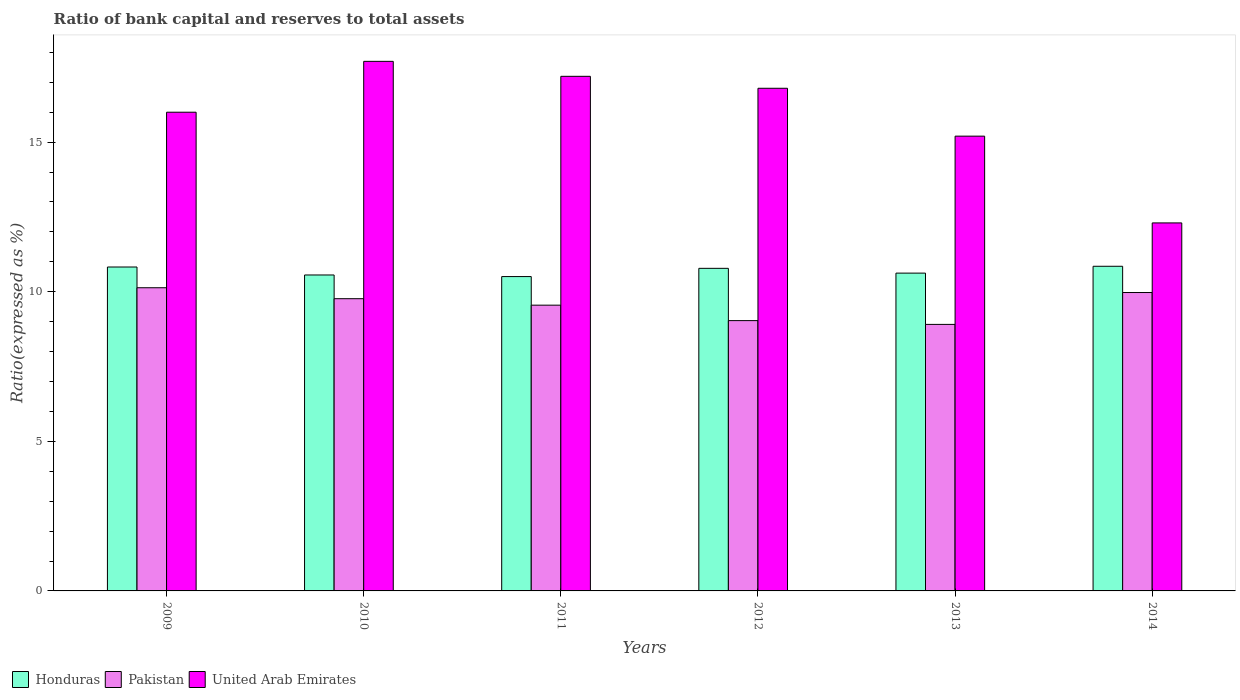How many different coloured bars are there?
Your response must be concise. 3. Are the number of bars per tick equal to the number of legend labels?
Ensure brevity in your answer.  Yes. Are the number of bars on each tick of the X-axis equal?
Ensure brevity in your answer.  Yes. How many bars are there on the 2nd tick from the left?
Make the answer very short. 3. In how many cases, is the number of bars for a given year not equal to the number of legend labels?
Your answer should be compact. 0. What is the ratio of bank capital and reserves to total assets in United Arab Emirates in 2010?
Provide a short and direct response. 17.7. Across all years, what is the maximum ratio of bank capital and reserves to total assets in Pakistan?
Your answer should be very brief. 10.13. Across all years, what is the minimum ratio of bank capital and reserves to total assets in United Arab Emirates?
Your answer should be very brief. 12.3. In which year was the ratio of bank capital and reserves to total assets in Honduras minimum?
Provide a short and direct response. 2011. What is the total ratio of bank capital and reserves to total assets in Pakistan in the graph?
Offer a terse response. 57.37. What is the difference between the ratio of bank capital and reserves to total assets in United Arab Emirates in 2010 and the ratio of bank capital and reserves to total assets in Pakistan in 2014?
Give a very brief answer. 7.73. What is the average ratio of bank capital and reserves to total assets in Pakistan per year?
Provide a succinct answer. 9.56. In the year 2013, what is the difference between the ratio of bank capital and reserves to total assets in Honduras and ratio of bank capital and reserves to total assets in Pakistan?
Your answer should be compact. 1.71. What is the ratio of the ratio of bank capital and reserves to total assets in Pakistan in 2010 to that in 2014?
Provide a succinct answer. 0.98. Is the ratio of bank capital and reserves to total assets in Honduras in 2013 less than that in 2014?
Offer a very short reply. Yes. What is the difference between the highest and the lowest ratio of bank capital and reserves to total assets in United Arab Emirates?
Make the answer very short. 5.4. Is the sum of the ratio of bank capital and reserves to total assets in Pakistan in 2009 and 2013 greater than the maximum ratio of bank capital and reserves to total assets in United Arab Emirates across all years?
Ensure brevity in your answer.  Yes. What does the 1st bar from the left in 2012 represents?
Provide a succinct answer. Honduras. What does the 2nd bar from the right in 2009 represents?
Offer a terse response. Pakistan. Is it the case that in every year, the sum of the ratio of bank capital and reserves to total assets in Honduras and ratio of bank capital and reserves to total assets in Pakistan is greater than the ratio of bank capital and reserves to total assets in United Arab Emirates?
Provide a succinct answer. Yes. How many bars are there?
Give a very brief answer. 18. What is the difference between two consecutive major ticks on the Y-axis?
Your answer should be compact. 5. Are the values on the major ticks of Y-axis written in scientific E-notation?
Your answer should be compact. No. How are the legend labels stacked?
Make the answer very short. Horizontal. What is the title of the graph?
Give a very brief answer. Ratio of bank capital and reserves to total assets. Does "Chile" appear as one of the legend labels in the graph?
Ensure brevity in your answer.  No. What is the label or title of the X-axis?
Make the answer very short. Years. What is the label or title of the Y-axis?
Ensure brevity in your answer.  Ratio(expressed as %). What is the Ratio(expressed as %) of Honduras in 2009?
Your response must be concise. 10.83. What is the Ratio(expressed as %) of Pakistan in 2009?
Offer a terse response. 10.13. What is the Ratio(expressed as %) in Honduras in 2010?
Offer a terse response. 10.56. What is the Ratio(expressed as %) in Pakistan in 2010?
Ensure brevity in your answer.  9.77. What is the Ratio(expressed as %) of United Arab Emirates in 2010?
Give a very brief answer. 17.7. What is the Ratio(expressed as %) of Honduras in 2011?
Ensure brevity in your answer.  10.51. What is the Ratio(expressed as %) of Pakistan in 2011?
Provide a succinct answer. 9.55. What is the Ratio(expressed as %) in United Arab Emirates in 2011?
Offer a very short reply. 17.2. What is the Ratio(expressed as %) of Honduras in 2012?
Provide a short and direct response. 10.78. What is the Ratio(expressed as %) in Pakistan in 2012?
Your answer should be very brief. 9.03. What is the Ratio(expressed as %) of United Arab Emirates in 2012?
Ensure brevity in your answer.  16.8. What is the Ratio(expressed as %) of Honduras in 2013?
Your answer should be very brief. 10.62. What is the Ratio(expressed as %) in Pakistan in 2013?
Your response must be concise. 8.91. What is the Ratio(expressed as %) of United Arab Emirates in 2013?
Offer a very short reply. 15.2. What is the Ratio(expressed as %) of Honduras in 2014?
Give a very brief answer. 10.85. What is the Ratio(expressed as %) in Pakistan in 2014?
Your response must be concise. 9.97. Across all years, what is the maximum Ratio(expressed as %) in Honduras?
Give a very brief answer. 10.85. Across all years, what is the maximum Ratio(expressed as %) of Pakistan?
Your answer should be compact. 10.13. Across all years, what is the maximum Ratio(expressed as %) in United Arab Emirates?
Provide a short and direct response. 17.7. Across all years, what is the minimum Ratio(expressed as %) of Honduras?
Your response must be concise. 10.51. Across all years, what is the minimum Ratio(expressed as %) in Pakistan?
Your response must be concise. 8.91. What is the total Ratio(expressed as %) of Honduras in the graph?
Make the answer very short. 64.15. What is the total Ratio(expressed as %) in Pakistan in the graph?
Provide a succinct answer. 57.37. What is the total Ratio(expressed as %) in United Arab Emirates in the graph?
Your response must be concise. 95.2. What is the difference between the Ratio(expressed as %) of Honduras in 2009 and that in 2010?
Provide a short and direct response. 0.27. What is the difference between the Ratio(expressed as %) of Pakistan in 2009 and that in 2010?
Your answer should be compact. 0.37. What is the difference between the Ratio(expressed as %) of United Arab Emirates in 2009 and that in 2010?
Keep it short and to the point. -1.7. What is the difference between the Ratio(expressed as %) of Honduras in 2009 and that in 2011?
Give a very brief answer. 0.32. What is the difference between the Ratio(expressed as %) of Pakistan in 2009 and that in 2011?
Keep it short and to the point. 0.58. What is the difference between the Ratio(expressed as %) in Honduras in 2009 and that in 2012?
Make the answer very short. 0.04. What is the difference between the Ratio(expressed as %) in Pakistan in 2009 and that in 2012?
Keep it short and to the point. 1.1. What is the difference between the Ratio(expressed as %) in United Arab Emirates in 2009 and that in 2012?
Ensure brevity in your answer.  -0.8. What is the difference between the Ratio(expressed as %) of Honduras in 2009 and that in 2013?
Your answer should be compact. 0.2. What is the difference between the Ratio(expressed as %) in Pakistan in 2009 and that in 2013?
Provide a succinct answer. 1.23. What is the difference between the Ratio(expressed as %) of United Arab Emirates in 2009 and that in 2013?
Your response must be concise. 0.8. What is the difference between the Ratio(expressed as %) in Honduras in 2009 and that in 2014?
Provide a short and direct response. -0.02. What is the difference between the Ratio(expressed as %) in Pakistan in 2009 and that in 2014?
Make the answer very short. 0.16. What is the difference between the Ratio(expressed as %) in Honduras in 2010 and that in 2011?
Offer a terse response. 0.05. What is the difference between the Ratio(expressed as %) in Pakistan in 2010 and that in 2011?
Offer a terse response. 0.22. What is the difference between the Ratio(expressed as %) of Honduras in 2010 and that in 2012?
Your response must be concise. -0.22. What is the difference between the Ratio(expressed as %) in Pakistan in 2010 and that in 2012?
Give a very brief answer. 0.73. What is the difference between the Ratio(expressed as %) in United Arab Emirates in 2010 and that in 2012?
Keep it short and to the point. 0.9. What is the difference between the Ratio(expressed as %) in Honduras in 2010 and that in 2013?
Your response must be concise. -0.06. What is the difference between the Ratio(expressed as %) of Pakistan in 2010 and that in 2013?
Offer a terse response. 0.86. What is the difference between the Ratio(expressed as %) of United Arab Emirates in 2010 and that in 2013?
Offer a very short reply. 2.5. What is the difference between the Ratio(expressed as %) of Honduras in 2010 and that in 2014?
Make the answer very short. -0.29. What is the difference between the Ratio(expressed as %) in Pakistan in 2010 and that in 2014?
Offer a very short reply. -0.21. What is the difference between the Ratio(expressed as %) of Honduras in 2011 and that in 2012?
Your answer should be compact. -0.28. What is the difference between the Ratio(expressed as %) in Pakistan in 2011 and that in 2012?
Make the answer very short. 0.52. What is the difference between the Ratio(expressed as %) in Honduras in 2011 and that in 2013?
Offer a terse response. -0.12. What is the difference between the Ratio(expressed as %) in Pakistan in 2011 and that in 2013?
Make the answer very short. 0.64. What is the difference between the Ratio(expressed as %) in United Arab Emirates in 2011 and that in 2013?
Ensure brevity in your answer.  2. What is the difference between the Ratio(expressed as %) in Honduras in 2011 and that in 2014?
Your response must be concise. -0.34. What is the difference between the Ratio(expressed as %) of Pakistan in 2011 and that in 2014?
Give a very brief answer. -0.42. What is the difference between the Ratio(expressed as %) of United Arab Emirates in 2011 and that in 2014?
Ensure brevity in your answer.  4.9. What is the difference between the Ratio(expressed as %) of Honduras in 2012 and that in 2013?
Offer a terse response. 0.16. What is the difference between the Ratio(expressed as %) in Pakistan in 2012 and that in 2013?
Your answer should be very brief. 0.13. What is the difference between the Ratio(expressed as %) of United Arab Emirates in 2012 and that in 2013?
Provide a succinct answer. 1.6. What is the difference between the Ratio(expressed as %) in Honduras in 2012 and that in 2014?
Your answer should be very brief. -0.07. What is the difference between the Ratio(expressed as %) in Pakistan in 2012 and that in 2014?
Your answer should be very brief. -0.94. What is the difference between the Ratio(expressed as %) of Honduras in 2013 and that in 2014?
Keep it short and to the point. -0.23. What is the difference between the Ratio(expressed as %) of Pakistan in 2013 and that in 2014?
Keep it short and to the point. -1.07. What is the difference between the Ratio(expressed as %) of Honduras in 2009 and the Ratio(expressed as %) of Pakistan in 2010?
Your response must be concise. 1.06. What is the difference between the Ratio(expressed as %) in Honduras in 2009 and the Ratio(expressed as %) in United Arab Emirates in 2010?
Your response must be concise. -6.87. What is the difference between the Ratio(expressed as %) of Pakistan in 2009 and the Ratio(expressed as %) of United Arab Emirates in 2010?
Give a very brief answer. -7.57. What is the difference between the Ratio(expressed as %) of Honduras in 2009 and the Ratio(expressed as %) of Pakistan in 2011?
Ensure brevity in your answer.  1.27. What is the difference between the Ratio(expressed as %) in Honduras in 2009 and the Ratio(expressed as %) in United Arab Emirates in 2011?
Offer a terse response. -6.37. What is the difference between the Ratio(expressed as %) in Pakistan in 2009 and the Ratio(expressed as %) in United Arab Emirates in 2011?
Offer a terse response. -7.07. What is the difference between the Ratio(expressed as %) in Honduras in 2009 and the Ratio(expressed as %) in Pakistan in 2012?
Keep it short and to the point. 1.79. What is the difference between the Ratio(expressed as %) of Honduras in 2009 and the Ratio(expressed as %) of United Arab Emirates in 2012?
Offer a very short reply. -5.97. What is the difference between the Ratio(expressed as %) of Pakistan in 2009 and the Ratio(expressed as %) of United Arab Emirates in 2012?
Provide a short and direct response. -6.67. What is the difference between the Ratio(expressed as %) in Honduras in 2009 and the Ratio(expressed as %) in Pakistan in 2013?
Make the answer very short. 1.92. What is the difference between the Ratio(expressed as %) of Honduras in 2009 and the Ratio(expressed as %) of United Arab Emirates in 2013?
Your response must be concise. -4.37. What is the difference between the Ratio(expressed as %) in Pakistan in 2009 and the Ratio(expressed as %) in United Arab Emirates in 2013?
Offer a very short reply. -5.07. What is the difference between the Ratio(expressed as %) of Honduras in 2009 and the Ratio(expressed as %) of Pakistan in 2014?
Make the answer very short. 0.85. What is the difference between the Ratio(expressed as %) in Honduras in 2009 and the Ratio(expressed as %) in United Arab Emirates in 2014?
Keep it short and to the point. -1.47. What is the difference between the Ratio(expressed as %) in Pakistan in 2009 and the Ratio(expressed as %) in United Arab Emirates in 2014?
Make the answer very short. -2.17. What is the difference between the Ratio(expressed as %) in Honduras in 2010 and the Ratio(expressed as %) in Pakistan in 2011?
Offer a very short reply. 1.01. What is the difference between the Ratio(expressed as %) of Honduras in 2010 and the Ratio(expressed as %) of United Arab Emirates in 2011?
Make the answer very short. -6.64. What is the difference between the Ratio(expressed as %) of Pakistan in 2010 and the Ratio(expressed as %) of United Arab Emirates in 2011?
Ensure brevity in your answer.  -7.43. What is the difference between the Ratio(expressed as %) of Honduras in 2010 and the Ratio(expressed as %) of Pakistan in 2012?
Give a very brief answer. 1.53. What is the difference between the Ratio(expressed as %) in Honduras in 2010 and the Ratio(expressed as %) in United Arab Emirates in 2012?
Your answer should be very brief. -6.24. What is the difference between the Ratio(expressed as %) of Pakistan in 2010 and the Ratio(expressed as %) of United Arab Emirates in 2012?
Ensure brevity in your answer.  -7.03. What is the difference between the Ratio(expressed as %) of Honduras in 2010 and the Ratio(expressed as %) of Pakistan in 2013?
Your response must be concise. 1.65. What is the difference between the Ratio(expressed as %) of Honduras in 2010 and the Ratio(expressed as %) of United Arab Emirates in 2013?
Your answer should be very brief. -4.64. What is the difference between the Ratio(expressed as %) of Pakistan in 2010 and the Ratio(expressed as %) of United Arab Emirates in 2013?
Provide a succinct answer. -5.43. What is the difference between the Ratio(expressed as %) in Honduras in 2010 and the Ratio(expressed as %) in Pakistan in 2014?
Offer a terse response. 0.59. What is the difference between the Ratio(expressed as %) in Honduras in 2010 and the Ratio(expressed as %) in United Arab Emirates in 2014?
Your response must be concise. -1.74. What is the difference between the Ratio(expressed as %) of Pakistan in 2010 and the Ratio(expressed as %) of United Arab Emirates in 2014?
Offer a terse response. -2.53. What is the difference between the Ratio(expressed as %) in Honduras in 2011 and the Ratio(expressed as %) in Pakistan in 2012?
Provide a short and direct response. 1.47. What is the difference between the Ratio(expressed as %) of Honduras in 2011 and the Ratio(expressed as %) of United Arab Emirates in 2012?
Ensure brevity in your answer.  -6.29. What is the difference between the Ratio(expressed as %) of Pakistan in 2011 and the Ratio(expressed as %) of United Arab Emirates in 2012?
Your answer should be compact. -7.25. What is the difference between the Ratio(expressed as %) in Honduras in 2011 and the Ratio(expressed as %) in Pakistan in 2013?
Keep it short and to the point. 1.6. What is the difference between the Ratio(expressed as %) of Honduras in 2011 and the Ratio(expressed as %) of United Arab Emirates in 2013?
Offer a very short reply. -4.69. What is the difference between the Ratio(expressed as %) in Pakistan in 2011 and the Ratio(expressed as %) in United Arab Emirates in 2013?
Provide a succinct answer. -5.65. What is the difference between the Ratio(expressed as %) of Honduras in 2011 and the Ratio(expressed as %) of Pakistan in 2014?
Your answer should be very brief. 0.53. What is the difference between the Ratio(expressed as %) of Honduras in 2011 and the Ratio(expressed as %) of United Arab Emirates in 2014?
Provide a short and direct response. -1.79. What is the difference between the Ratio(expressed as %) of Pakistan in 2011 and the Ratio(expressed as %) of United Arab Emirates in 2014?
Your response must be concise. -2.75. What is the difference between the Ratio(expressed as %) of Honduras in 2012 and the Ratio(expressed as %) of Pakistan in 2013?
Give a very brief answer. 1.87. What is the difference between the Ratio(expressed as %) of Honduras in 2012 and the Ratio(expressed as %) of United Arab Emirates in 2013?
Your answer should be compact. -4.42. What is the difference between the Ratio(expressed as %) of Pakistan in 2012 and the Ratio(expressed as %) of United Arab Emirates in 2013?
Provide a short and direct response. -6.17. What is the difference between the Ratio(expressed as %) of Honduras in 2012 and the Ratio(expressed as %) of Pakistan in 2014?
Ensure brevity in your answer.  0.81. What is the difference between the Ratio(expressed as %) of Honduras in 2012 and the Ratio(expressed as %) of United Arab Emirates in 2014?
Provide a short and direct response. -1.52. What is the difference between the Ratio(expressed as %) in Pakistan in 2012 and the Ratio(expressed as %) in United Arab Emirates in 2014?
Offer a terse response. -3.27. What is the difference between the Ratio(expressed as %) in Honduras in 2013 and the Ratio(expressed as %) in Pakistan in 2014?
Your answer should be very brief. 0.65. What is the difference between the Ratio(expressed as %) of Honduras in 2013 and the Ratio(expressed as %) of United Arab Emirates in 2014?
Your answer should be compact. -1.68. What is the difference between the Ratio(expressed as %) of Pakistan in 2013 and the Ratio(expressed as %) of United Arab Emirates in 2014?
Your response must be concise. -3.39. What is the average Ratio(expressed as %) of Honduras per year?
Your answer should be compact. 10.69. What is the average Ratio(expressed as %) in Pakistan per year?
Provide a succinct answer. 9.56. What is the average Ratio(expressed as %) of United Arab Emirates per year?
Provide a succinct answer. 15.87. In the year 2009, what is the difference between the Ratio(expressed as %) in Honduras and Ratio(expressed as %) in Pakistan?
Give a very brief answer. 0.69. In the year 2009, what is the difference between the Ratio(expressed as %) in Honduras and Ratio(expressed as %) in United Arab Emirates?
Your response must be concise. -5.17. In the year 2009, what is the difference between the Ratio(expressed as %) in Pakistan and Ratio(expressed as %) in United Arab Emirates?
Offer a very short reply. -5.87. In the year 2010, what is the difference between the Ratio(expressed as %) of Honduras and Ratio(expressed as %) of Pakistan?
Provide a succinct answer. 0.79. In the year 2010, what is the difference between the Ratio(expressed as %) in Honduras and Ratio(expressed as %) in United Arab Emirates?
Your answer should be very brief. -7.14. In the year 2010, what is the difference between the Ratio(expressed as %) in Pakistan and Ratio(expressed as %) in United Arab Emirates?
Make the answer very short. -7.93. In the year 2011, what is the difference between the Ratio(expressed as %) of Honduras and Ratio(expressed as %) of Pakistan?
Give a very brief answer. 0.96. In the year 2011, what is the difference between the Ratio(expressed as %) in Honduras and Ratio(expressed as %) in United Arab Emirates?
Your response must be concise. -6.69. In the year 2011, what is the difference between the Ratio(expressed as %) in Pakistan and Ratio(expressed as %) in United Arab Emirates?
Make the answer very short. -7.65. In the year 2012, what is the difference between the Ratio(expressed as %) of Honduras and Ratio(expressed as %) of Pakistan?
Provide a succinct answer. 1.75. In the year 2012, what is the difference between the Ratio(expressed as %) in Honduras and Ratio(expressed as %) in United Arab Emirates?
Make the answer very short. -6.02. In the year 2012, what is the difference between the Ratio(expressed as %) in Pakistan and Ratio(expressed as %) in United Arab Emirates?
Make the answer very short. -7.77. In the year 2013, what is the difference between the Ratio(expressed as %) of Honduras and Ratio(expressed as %) of Pakistan?
Keep it short and to the point. 1.71. In the year 2013, what is the difference between the Ratio(expressed as %) in Honduras and Ratio(expressed as %) in United Arab Emirates?
Provide a short and direct response. -4.58. In the year 2013, what is the difference between the Ratio(expressed as %) of Pakistan and Ratio(expressed as %) of United Arab Emirates?
Offer a terse response. -6.29. In the year 2014, what is the difference between the Ratio(expressed as %) of Honduras and Ratio(expressed as %) of Pakistan?
Make the answer very short. 0.88. In the year 2014, what is the difference between the Ratio(expressed as %) of Honduras and Ratio(expressed as %) of United Arab Emirates?
Provide a short and direct response. -1.45. In the year 2014, what is the difference between the Ratio(expressed as %) in Pakistan and Ratio(expressed as %) in United Arab Emirates?
Ensure brevity in your answer.  -2.33. What is the ratio of the Ratio(expressed as %) of Honduras in 2009 to that in 2010?
Your response must be concise. 1.03. What is the ratio of the Ratio(expressed as %) of Pakistan in 2009 to that in 2010?
Your response must be concise. 1.04. What is the ratio of the Ratio(expressed as %) in United Arab Emirates in 2009 to that in 2010?
Keep it short and to the point. 0.9. What is the ratio of the Ratio(expressed as %) of Honduras in 2009 to that in 2011?
Ensure brevity in your answer.  1.03. What is the ratio of the Ratio(expressed as %) in Pakistan in 2009 to that in 2011?
Your answer should be very brief. 1.06. What is the ratio of the Ratio(expressed as %) of United Arab Emirates in 2009 to that in 2011?
Your response must be concise. 0.93. What is the ratio of the Ratio(expressed as %) of Honduras in 2009 to that in 2012?
Ensure brevity in your answer.  1. What is the ratio of the Ratio(expressed as %) of Pakistan in 2009 to that in 2012?
Your answer should be very brief. 1.12. What is the ratio of the Ratio(expressed as %) in Honduras in 2009 to that in 2013?
Give a very brief answer. 1.02. What is the ratio of the Ratio(expressed as %) in Pakistan in 2009 to that in 2013?
Your response must be concise. 1.14. What is the ratio of the Ratio(expressed as %) in United Arab Emirates in 2009 to that in 2013?
Your answer should be compact. 1.05. What is the ratio of the Ratio(expressed as %) of United Arab Emirates in 2009 to that in 2014?
Offer a terse response. 1.3. What is the ratio of the Ratio(expressed as %) of Honduras in 2010 to that in 2011?
Make the answer very short. 1.01. What is the ratio of the Ratio(expressed as %) of Pakistan in 2010 to that in 2011?
Make the answer very short. 1.02. What is the ratio of the Ratio(expressed as %) in United Arab Emirates in 2010 to that in 2011?
Provide a short and direct response. 1.03. What is the ratio of the Ratio(expressed as %) in Honduras in 2010 to that in 2012?
Offer a very short reply. 0.98. What is the ratio of the Ratio(expressed as %) of Pakistan in 2010 to that in 2012?
Keep it short and to the point. 1.08. What is the ratio of the Ratio(expressed as %) of United Arab Emirates in 2010 to that in 2012?
Your answer should be compact. 1.05. What is the ratio of the Ratio(expressed as %) in Pakistan in 2010 to that in 2013?
Provide a succinct answer. 1.1. What is the ratio of the Ratio(expressed as %) in United Arab Emirates in 2010 to that in 2013?
Your response must be concise. 1.16. What is the ratio of the Ratio(expressed as %) in Honduras in 2010 to that in 2014?
Provide a succinct answer. 0.97. What is the ratio of the Ratio(expressed as %) in Pakistan in 2010 to that in 2014?
Keep it short and to the point. 0.98. What is the ratio of the Ratio(expressed as %) in United Arab Emirates in 2010 to that in 2014?
Keep it short and to the point. 1.44. What is the ratio of the Ratio(expressed as %) of Honduras in 2011 to that in 2012?
Give a very brief answer. 0.97. What is the ratio of the Ratio(expressed as %) in Pakistan in 2011 to that in 2012?
Offer a terse response. 1.06. What is the ratio of the Ratio(expressed as %) of United Arab Emirates in 2011 to that in 2012?
Keep it short and to the point. 1.02. What is the ratio of the Ratio(expressed as %) in Pakistan in 2011 to that in 2013?
Give a very brief answer. 1.07. What is the ratio of the Ratio(expressed as %) of United Arab Emirates in 2011 to that in 2013?
Your answer should be very brief. 1.13. What is the ratio of the Ratio(expressed as %) of Honduras in 2011 to that in 2014?
Offer a very short reply. 0.97. What is the ratio of the Ratio(expressed as %) in Pakistan in 2011 to that in 2014?
Make the answer very short. 0.96. What is the ratio of the Ratio(expressed as %) of United Arab Emirates in 2011 to that in 2014?
Offer a very short reply. 1.4. What is the ratio of the Ratio(expressed as %) in Honduras in 2012 to that in 2013?
Provide a succinct answer. 1.01. What is the ratio of the Ratio(expressed as %) of Pakistan in 2012 to that in 2013?
Keep it short and to the point. 1.01. What is the ratio of the Ratio(expressed as %) in United Arab Emirates in 2012 to that in 2013?
Give a very brief answer. 1.11. What is the ratio of the Ratio(expressed as %) of Honduras in 2012 to that in 2014?
Provide a short and direct response. 0.99. What is the ratio of the Ratio(expressed as %) in Pakistan in 2012 to that in 2014?
Offer a terse response. 0.91. What is the ratio of the Ratio(expressed as %) in United Arab Emirates in 2012 to that in 2014?
Provide a short and direct response. 1.37. What is the ratio of the Ratio(expressed as %) in Honduras in 2013 to that in 2014?
Offer a terse response. 0.98. What is the ratio of the Ratio(expressed as %) of Pakistan in 2013 to that in 2014?
Offer a very short reply. 0.89. What is the ratio of the Ratio(expressed as %) in United Arab Emirates in 2013 to that in 2014?
Give a very brief answer. 1.24. What is the difference between the highest and the second highest Ratio(expressed as %) of Honduras?
Your answer should be very brief. 0.02. What is the difference between the highest and the second highest Ratio(expressed as %) in Pakistan?
Your response must be concise. 0.16. What is the difference between the highest and the second highest Ratio(expressed as %) of United Arab Emirates?
Keep it short and to the point. 0.5. What is the difference between the highest and the lowest Ratio(expressed as %) of Honduras?
Provide a short and direct response. 0.34. What is the difference between the highest and the lowest Ratio(expressed as %) of Pakistan?
Your answer should be compact. 1.23. 